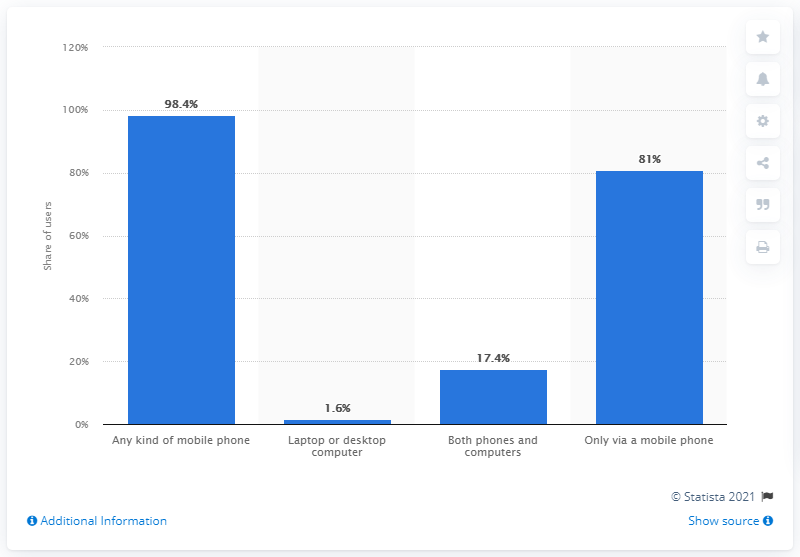Point out several critical features in this image. In April 2021, 98.4% of Facebook's active users worldwide used a mobile phone to access the platform, indicating a strong reliance on mobile devices for social media engagement. 